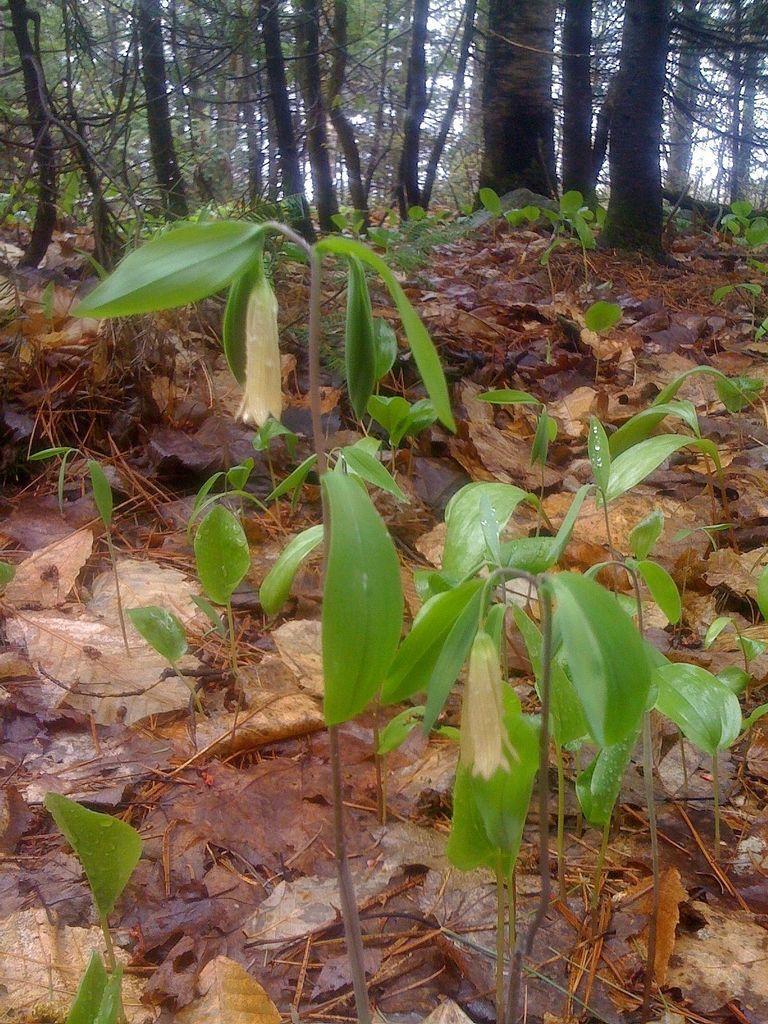Can you describe this image briefly? In this picture we can see plants and dried leaves on the ground. In the background we can see trees. 